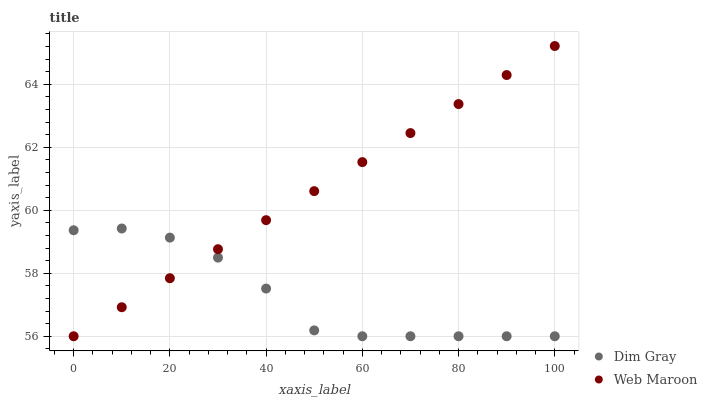Does Dim Gray have the minimum area under the curve?
Answer yes or no. Yes. Does Web Maroon have the maximum area under the curve?
Answer yes or no. Yes. Does Web Maroon have the minimum area under the curve?
Answer yes or no. No. Is Web Maroon the smoothest?
Answer yes or no. Yes. Is Dim Gray the roughest?
Answer yes or no. Yes. Is Web Maroon the roughest?
Answer yes or no. No. Does Dim Gray have the lowest value?
Answer yes or no. Yes. Does Web Maroon have the highest value?
Answer yes or no. Yes. Does Web Maroon intersect Dim Gray?
Answer yes or no. Yes. Is Web Maroon less than Dim Gray?
Answer yes or no. No. Is Web Maroon greater than Dim Gray?
Answer yes or no. No. 